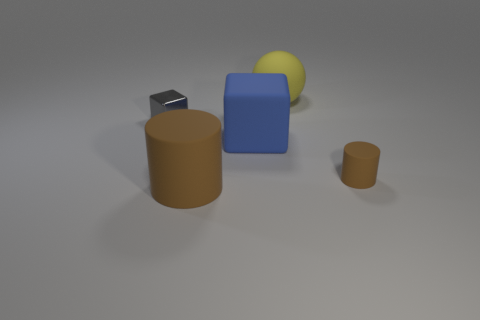The object on the left side of the large matte cylinder is what color?
Your response must be concise. Gray. Is there another large brown object of the same shape as the big brown object?
Ensure brevity in your answer.  No. What material is the small brown cylinder?
Provide a short and direct response. Rubber. How big is the object that is both behind the blue matte cube and right of the gray cube?
Your response must be concise. Large. There is another cylinder that is the same color as the big rubber cylinder; what is it made of?
Your answer should be very brief. Rubber. How many big green matte blocks are there?
Make the answer very short. 0. Is the number of large cylinders less than the number of large purple balls?
Provide a succinct answer. No. There is a cylinder that is the same size as the gray metal thing; what material is it?
Ensure brevity in your answer.  Rubber. What number of things are small things or yellow metal cylinders?
Offer a terse response. 2. How many cylinders are both left of the large blue object and behind the big brown rubber cylinder?
Your answer should be compact. 0. 